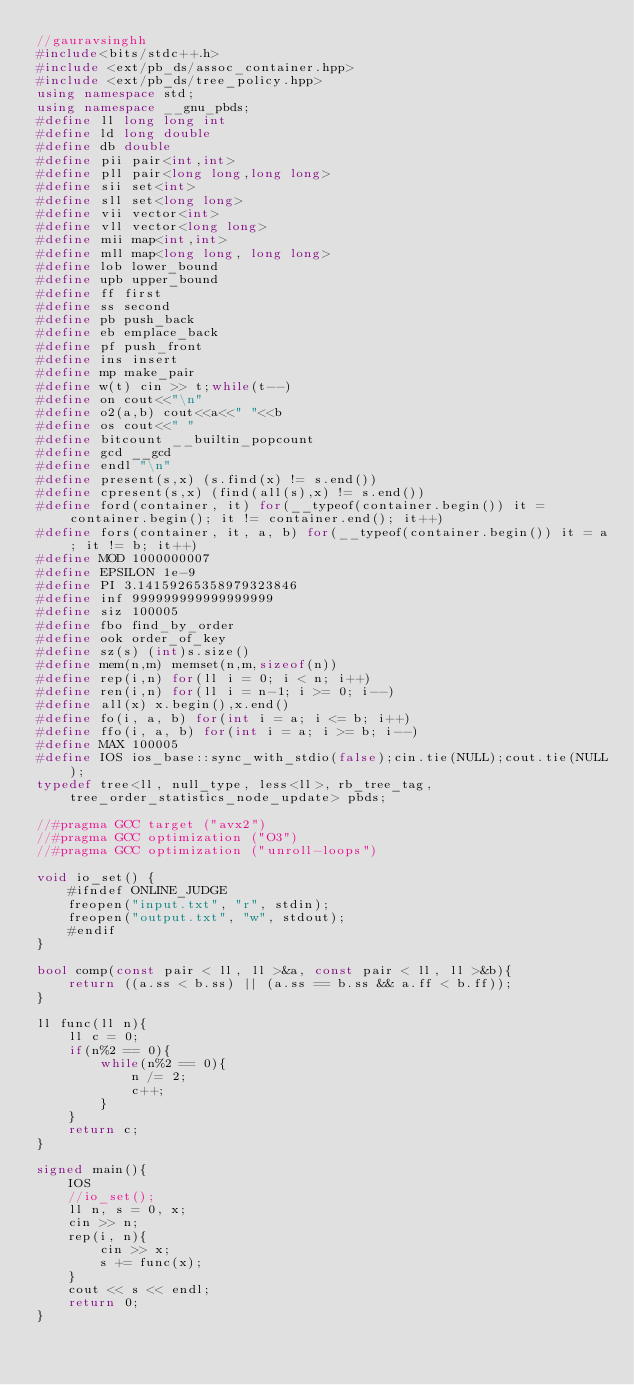<code> <loc_0><loc_0><loc_500><loc_500><_C++_>//gauravsinghh
#include<bits/stdc++.h>
#include <ext/pb_ds/assoc_container.hpp>
#include <ext/pb_ds/tree_policy.hpp>
using namespace std;
using namespace __gnu_pbds;
#define ll long long int
#define ld long double
#define db double
#define pii pair<int,int>
#define pll pair<long long,long long>
#define sii set<int>
#define sll set<long long>
#define vii vector<int> 
#define vll vector<long long>
#define mii map<int,int>
#define mll map<long long, long long>
#define lob lower_bound
#define upb upper_bound
#define ff first
#define ss second
#define pb push_back
#define eb emplace_back
#define pf push_front
#define ins insert
#define mp make_pair
#define w(t) cin >> t;while(t--)
#define on cout<<"\n"
#define o2(a,b) cout<<a<<" "<<b
#define os cout<<" "
#define bitcount __builtin_popcount
#define gcd __gcd
#define endl "\n"
#define present(s,x) (s.find(x) != s.end()) 
#define cpresent(s,x) (find(all(s),x) != s.end()) 
#define ford(container, it) for(__typeof(container.begin()) it = container.begin(); it != container.end(); it++) 
#define fors(container, it, a, b) for(__typeof(container.begin()) it = a; it != b; it++) 
#define MOD 1000000007
#define EPSILON 1e-9
#define PI 3.14159265358979323846
#define inf 999999999999999999
#define siz 100005
#define fbo find_by_order
#define ook order_of_key
#define sz(s) (int)s.size()
#define mem(n,m) memset(n,m,sizeof(n))
#define rep(i,n) for(ll i = 0; i < n; i++)
#define ren(i,n) for(ll i = n-1; i >= 0; i--)
#define all(x) x.begin(),x.end()
#define fo(i, a, b) for(int i = a; i <= b; i++)
#define ffo(i, a, b) for(int i = a; i >= b; i--)
#define MAX 100005
#define IOS ios_base::sync_with_stdio(false);cin.tie(NULL);cout.tie(NULL);
typedef tree<ll, null_type, less<ll>, rb_tree_tag, tree_order_statistics_node_update> pbds;

//#pragma GCC target ("avx2")
//#pragma GCC optimization ("O3")
//#pragma GCC optimization ("unroll-loops")

void io_set() {
    #ifndef ONLINE_JUDGE
    freopen("input.txt", "r", stdin);
    freopen("output.txt", "w", stdout);
    #endif
}

bool comp(const pair < ll, ll >&a, const pair < ll, ll >&b){
    return ((a.ss < b.ss) || (a.ss == b.ss && a.ff < b.ff));
}

ll func(ll n){
    ll c = 0;
    if(n%2 == 0){
        while(n%2 == 0){
            n /= 2;
            c++;
        }
    }
    return c;
}

signed main(){ 
    IOS
    //io_set();
    ll n, s = 0, x;
    cin >> n;
    rep(i, n){
        cin >> x;
        s += func(x);
    }
    cout << s << endl;
    return 0;
}

</code> 